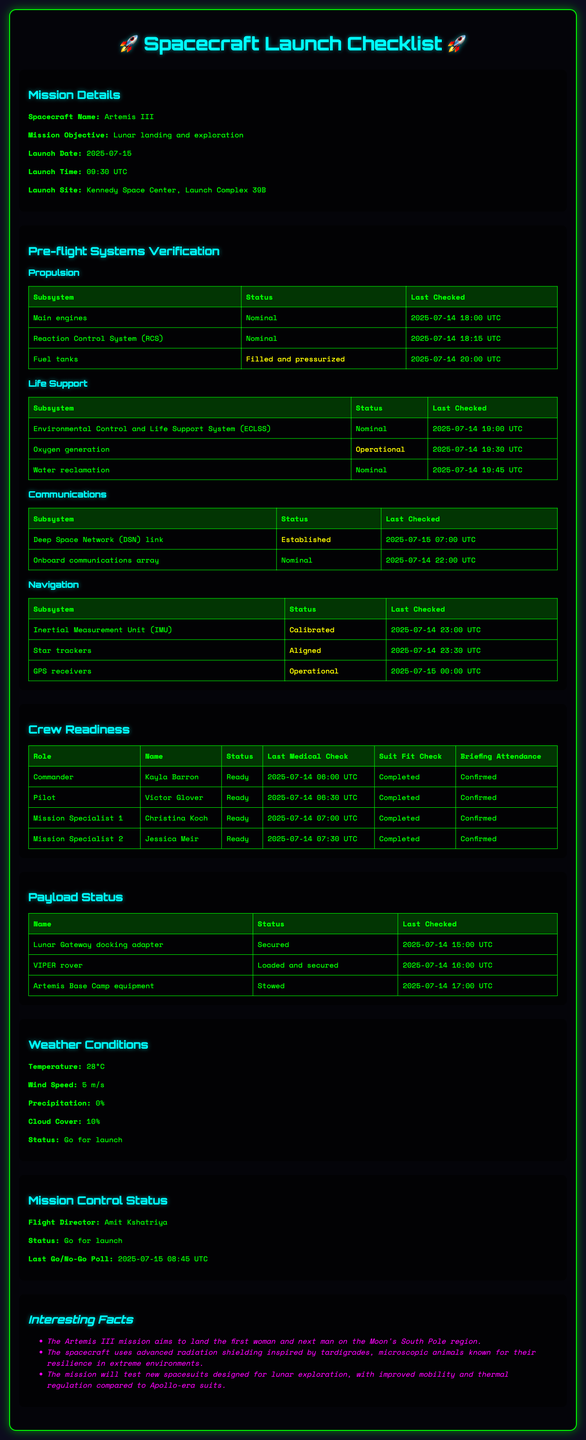what is the spacecraft name? The spacecraft name is mentioned in the document as the title of the mission details section.
Answer: Artemis III what is the mission objective? The mission objective is described in the mission details section of the document.
Answer: Lunar landing and exploration when is the launch date? The launch date is specified in the mission details section.
Answer: 2025-07-15 who is the commander? The name and role of the commander are listed in the crew readiness section of the document.
Answer: Kayla Barron what is the status of the oxygen generation subsystem? The status is provided in the pre-flight systems verification under Life Support systems.
Answer: Operational what was the last medical check date for the pilot? The date of the last medical check for the pilot is noted in the crew readiness details.
Answer: 2025-07-14 06:30 UTC how many subsystems are listed under propulsion? The number of subsystems listed can be counted from the propulsion system details.
Answer: 3 what is the status of the Lunar Gateway docking adapter? The status of the payload is highlighted in the payload status section of the document.
Answer: Secured what is the last go/no-go poll time? The time of the last go/no-go poll is mentioned in the mission control status section.
Answer: 2025-07-15 08:45 UTC 